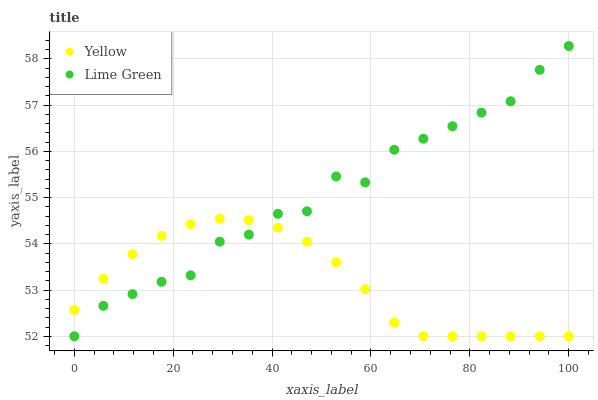Does Yellow have the minimum area under the curve?
Answer yes or no. Yes. Does Lime Green have the maximum area under the curve?
Answer yes or no. Yes. Does Yellow have the maximum area under the curve?
Answer yes or no. No. Is Yellow the smoothest?
Answer yes or no. Yes. Is Lime Green the roughest?
Answer yes or no. Yes. Is Yellow the roughest?
Answer yes or no. No. Does Lime Green have the lowest value?
Answer yes or no. Yes. Does Lime Green have the highest value?
Answer yes or no. Yes. Does Yellow have the highest value?
Answer yes or no. No. Does Lime Green intersect Yellow?
Answer yes or no. Yes. Is Lime Green less than Yellow?
Answer yes or no. No. Is Lime Green greater than Yellow?
Answer yes or no. No. 